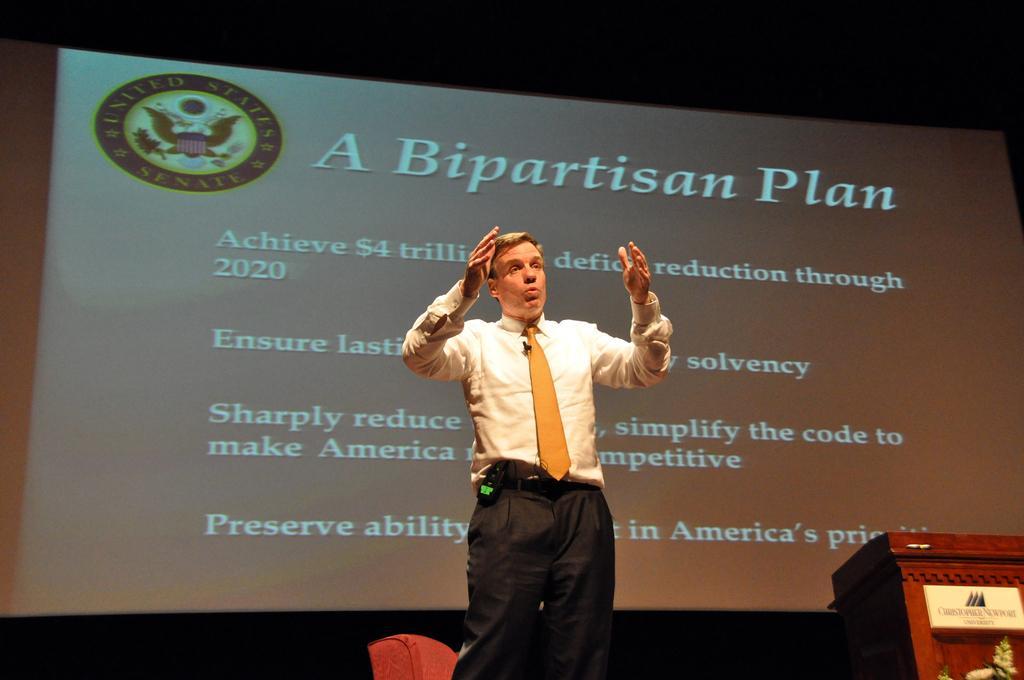Could you give a brief overview of what you see in this image? As we can see in the image there is screen and a man wearing white color shirt. On screen there is something written. 